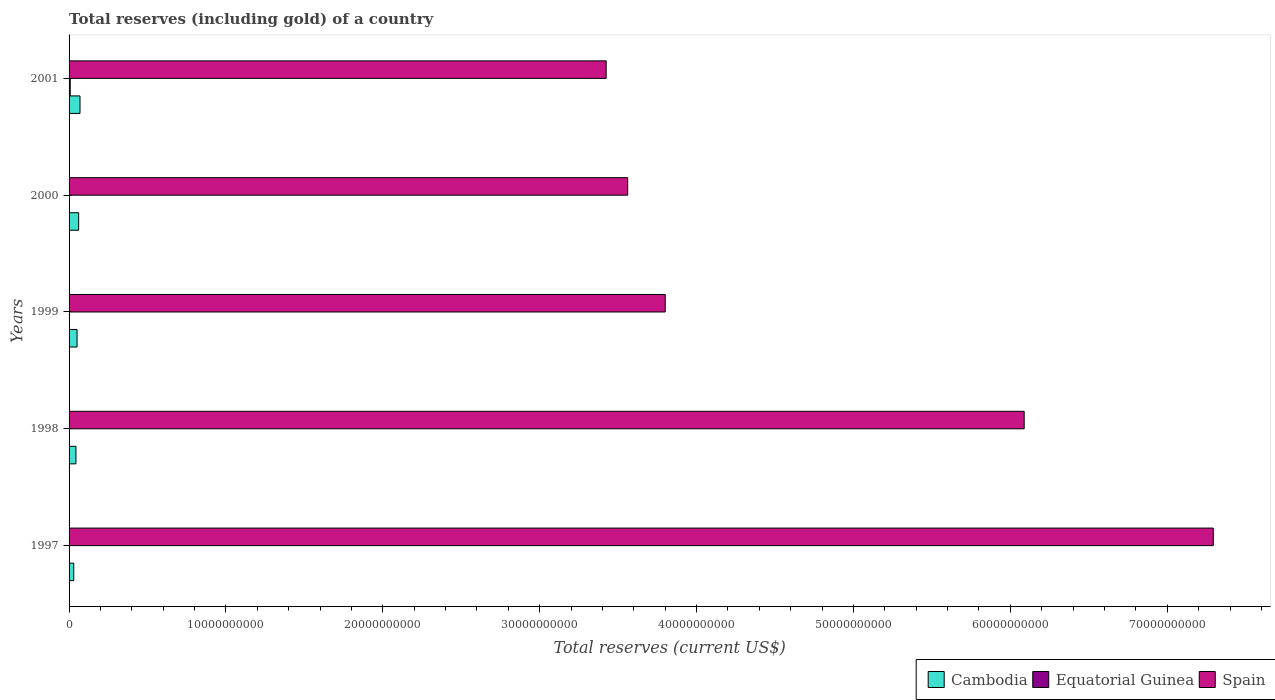How many groups of bars are there?
Your answer should be compact. 5. Are the number of bars per tick equal to the number of legend labels?
Your response must be concise. Yes. Are the number of bars on each tick of the Y-axis equal?
Your answer should be very brief. Yes. How many bars are there on the 3rd tick from the top?
Your response must be concise. 3. How many bars are there on the 1st tick from the bottom?
Your answer should be compact. 3. What is the label of the 1st group of bars from the top?
Keep it short and to the point. 2001. In how many cases, is the number of bars for a given year not equal to the number of legend labels?
Give a very brief answer. 0. What is the total reserves (including gold) in Equatorial Guinea in 1997?
Keep it short and to the point. 4.93e+06. Across all years, what is the maximum total reserves (including gold) in Spain?
Offer a terse response. 7.29e+1. Across all years, what is the minimum total reserves (including gold) in Equatorial Guinea?
Provide a short and direct response. 8.03e+05. In which year was the total reserves (including gold) in Cambodia maximum?
Give a very brief answer. 2001. What is the total total reserves (including gold) in Cambodia in the graph?
Ensure brevity in your answer.  2.56e+09. What is the difference between the total reserves (including gold) in Cambodia in 1999 and that in 2001?
Provide a succinct answer. -1.88e+08. What is the difference between the total reserves (including gold) in Equatorial Guinea in 2000 and the total reserves (including gold) in Cambodia in 1998?
Provide a succinct answer. -4.16e+08. What is the average total reserves (including gold) in Spain per year?
Give a very brief answer. 4.83e+1. In the year 1997, what is the difference between the total reserves (including gold) in Spain and total reserves (including gold) in Equatorial Guinea?
Offer a terse response. 7.29e+1. What is the ratio of the total reserves (including gold) in Cambodia in 1997 to that in 2000?
Offer a terse response. 0.49. Is the difference between the total reserves (including gold) in Spain in 1998 and 2000 greater than the difference between the total reserves (including gold) in Equatorial Guinea in 1998 and 2000?
Your answer should be very brief. Yes. What is the difference between the highest and the second highest total reserves (including gold) in Spain?
Ensure brevity in your answer.  1.21e+1. What is the difference between the highest and the lowest total reserves (including gold) in Cambodia?
Offer a very short reply. 3.99e+08. In how many years, is the total reserves (including gold) in Equatorial Guinea greater than the average total reserves (including gold) in Equatorial Guinea taken over all years?
Make the answer very short. 2. Is the sum of the total reserves (including gold) in Cambodia in 1999 and 2001 greater than the maximum total reserves (including gold) in Equatorial Guinea across all years?
Your answer should be very brief. Yes. What does the 2nd bar from the top in 1997 represents?
Provide a succinct answer. Equatorial Guinea. What does the 1st bar from the bottom in 1998 represents?
Provide a succinct answer. Cambodia. How are the legend labels stacked?
Offer a very short reply. Horizontal. What is the title of the graph?
Your answer should be very brief. Total reserves (including gold) of a country. Does "Syrian Arab Republic" appear as one of the legend labels in the graph?
Ensure brevity in your answer.  No. What is the label or title of the X-axis?
Provide a short and direct response. Total reserves (current US$). What is the Total reserves (current US$) in Cambodia in 1997?
Give a very brief answer. 2.99e+08. What is the Total reserves (current US$) of Equatorial Guinea in 1997?
Your response must be concise. 4.93e+06. What is the Total reserves (current US$) of Spain in 1997?
Your answer should be very brief. 7.29e+1. What is the Total reserves (current US$) of Cambodia in 1998?
Give a very brief answer. 4.39e+08. What is the Total reserves (current US$) of Equatorial Guinea in 1998?
Offer a very short reply. 8.03e+05. What is the Total reserves (current US$) of Spain in 1998?
Your response must be concise. 6.09e+1. What is the Total reserves (current US$) of Cambodia in 1999?
Keep it short and to the point. 5.09e+08. What is the Total reserves (current US$) in Equatorial Guinea in 1999?
Ensure brevity in your answer.  3.35e+06. What is the Total reserves (current US$) in Spain in 1999?
Offer a terse response. 3.80e+1. What is the Total reserves (current US$) in Cambodia in 2000?
Give a very brief answer. 6.11e+08. What is the Total reserves (current US$) in Equatorial Guinea in 2000?
Offer a very short reply. 2.30e+07. What is the Total reserves (current US$) in Spain in 2000?
Offer a terse response. 3.56e+1. What is the Total reserves (current US$) of Cambodia in 2001?
Offer a very short reply. 6.97e+08. What is the Total reserves (current US$) in Equatorial Guinea in 2001?
Ensure brevity in your answer.  7.09e+07. What is the Total reserves (current US$) in Spain in 2001?
Make the answer very short. 3.42e+1. Across all years, what is the maximum Total reserves (current US$) in Cambodia?
Offer a terse response. 6.97e+08. Across all years, what is the maximum Total reserves (current US$) in Equatorial Guinea?
Provide a succinct answer. 7.09e+07. Across all years, what is the maximum Total reserves (current US$) of Spain?
Offer a very short reply. 7.29e+1. Across all years, what is the minimum Total reserves (current US$) in Cambodia?
Your response must be concise. 2.99e+08. Across all years, what is the minimum Total reserves (current US$) of Equatorial Guinea?
Make the answer very short. 8.03e+05. Across all years, what is the minimum Total reserves (current US$) in Spain?
Your answer should be very brief. 3.42e+1. What is the total Total reserves (current US$) in Cambodia in the graph?
Your response must be concise. 2.56e+09. What is the total Total reserves (current US$) of Equatorial Guinea in the graph?
Give a very brief answer. 1.03e+08. What is the total Total reserves (current US$) in Spain in the graph?
Offer a terse response. 2.42e+11. What is the difference between the Total reserves (current US$) in Cambodia in 1997 and that in 1998?
Provide a short and direct response. -1.41e+08. What is the difference between the Total reserves (current US$) of Equatorial Guinea in 1997 and that in 1998?
Offer a very short reply. 4.13e+06. What is the difference between the Total reserves (current US$) of Spain in 1997 and that in 1998?
Your response must be concise. 1.21e+1. What is the difference between the Total reserves (current US$) of Cambodia in 1997 and that in 1999?
Your response must be concise. -2.11e+08. What is the difference between the Total reserves (current US$) in Equatorial Guinea in 1997 and that in 1999?
Offer a terse response. 1.58e+06. What is the difference between the Total reserves (current US$) in Spain in 1997 and that in 1999?
Your answer should be compact. 3.49e+1. What is the difference between the Total reserves (current US$) in Cambodia in 1997 and that in 2000?
Provide a short and direct response. -3.13e+08. What is the difference between the Total reserves (current US$) of Equatorial Guinea in 1997 and that in 2000?
Offer a very short reply. -1.81e+07. What is the difference between the Total reserves (current US$) of Spain in 1997 and that in 2000?
Make the answer very short. 3.73e+1. What is the difference between the Total reserves (current US$) in Cambodia in 1997 and that in 2001?
Make the answer very short. -3.99e+08. What is the difference between the Total reserves (current US$) of Equatorial Guinea in 1997 and that in 2001?
Your answer should be compact. -6.59e+07. What is the difference between the Total reserves (current US$) in Spain in 1997 and that in 2001?
Offer a very short reply. 3.87e+1. What is the difference between the Total reserves (current US$) in Cambodia in 1998 and that in 1999?
Your answer should be very brief. -6.98e+07. What is the difference between the Total reserves (current US$) of Equatorial Guinea in 1998 and that in 1999?
Make the answer very short. -2.55e+06. What is the difference between the Total reserves (current US$) in Spain in 1998 and that in 1999?
Make the answer very short. 2.29e+1. What is the difference between the Total reserves (current US$) of Cambodia in 1998 and that in 2000?
Your response must be concise. -1.72e+08. What is the difference between the Total reserves (current US$) of Equatorial Guinea in 1998 and that in 2000?
Make the answer very short. -2.22e+07. What is the difference between the Total reserves (current US$) of Spain in 1998 and that in 2000?
Keep it short and to the point. 2.53e+1. What is the difference between the Total reserves (current US$) in Cambodia in 1998 and that in 2001?
Provide a short and direct response. -2.58e+08. What is the difference between the Total reserves (current US$) of Equatorial Guinea in 1998 and that in 2001?
Offer a terse response. -7.00e+07. What is the difference between the Total reserves (current US$) in Spain in 1998 and that in 2001?
Your answer should be very brief. 2.66e+1. What is the difference between the Total reserves (current US$) of Cambodia in 1999 and that in 2000?
Your answer should be very brief. -1.02e+08. What is the difference between the Total reserves (current US$) in Equatorial Guinea in 1999 and that in 2000?
Your answer should be very brief. -1.97e+07. What is the difference between the Total reserves (current US$) of Spain in 1999 and that in 2000?
Your response must be concise. 2.39e+09. What is the difference between the Total reserves (current US$) of Cambodia in 1999 and that in 2001?
Keep it short and to the point. -1.88e+08. What is the difference between the Total reserves (current US$) in Equatorial Guinea in 1999 and that in 2001?
Ensure brevity in your answer.  -6.75e+07. What is the difference between the Total reserves (current US$) in Spain in 1999 and that in 2001?
Your response must be concise. 3.76e+09. What is the difference between the Total reserves (current US$) of Cambodia in 2000 and that in 2001?
Your response must be concise. -8.59e+07. What is the difference between the Total reserves (current US$) of Equatorial Guinea in 2000 and that in 2001?
Offer a terse response. -4.78e+07. What is the difference between the Total reserves (current US$) in Spain in 2000 and that in 2001?
Your answer should be very brief. 1.37e+09. What is the difference between the Total reserves (current US$) in Cambodia in 1997 and the Total reserves (current US$) in Equatorial Guinea in 1998?
Ensure brevity in your answer.  2.98e+08. What is the difference between the Total reserves (current US$) of Cambodia in 1997 and the Total reserves (current US$) of Spain in 1998?
Your answer should be compact. -6.06e+1. What is the difference between the Total reserves (current US$) in Equatorial Guinea in 1997 and the Total reserves (current US$) in Spain in 1998?
Offer a very short reply. -6.09e+1. What is the difference between the Total reserves (current US$) in Cambodia in 1997 and the Total reserves (current US$) in Equatorial Guinea in 1999?
Your response must be concise. 2.95e+08. What is the difference between the Total reserves (current US$) in Cambodia in 1997 and the Total reserves (current US$) in Spain in 1999?
Keep it short and to the point. -3.77e+1. What is the difference between the Total reserves (current US$) in Equatorial Guinea in 1997 and the Total reserves (current US$) in Spain in 1999?
Offer a very short reply. -3.80e+1. What is the difference between the Total reserves (current US$) of Cambodia in 1997 and the Total reserves (current US$) of Equatorial Guinea in 2000?
Provide a short and direct response. 2.76e+08. What is the difference between the Total reserves (current US$) in Cambodia in 1997 and the Total reserves (current US$) in Spain in 2000?
Offer a terse response. -3.53e+1. What is the difference between the Total reserves (current US$) in Equatorial Guinea in 1997 and the Total reserves (current US$) in Spain in 2000?
Keep it short and to the point. -3.56e+1. What is the difference between the Total reserves (current US$) in Cambodia in 1997 and the Total reserves (current US$) in Equatorial Guinea in 2001?
Your response must be concise. 2.28e+08. What is the difference between the Total reserves (current US$) in Cambodia in 1997 and the Total reserves (current US$) in Spain in 2001?
Make the answer very short. -3.39e+1. What is the difference between the Total reserves (current US$) of Equatorial Guinea in 1997 and the Total reserves (current US$) of Spain in 2001?
Offer a very short reply. -3.42e+1. What is the difference between the Total reserves (current US$) in Cambodia in 1998 and the Total reserves (current US$) in Equatorial Guinea in 1999?
Your response must be concise. 4.36e+08. What is the difference between the Total reserves (current US$) of Cambodia in 1998 and the Total reserves (current US$) of Spain in 1999?
Your answer should be compact. -3.76e+1. What is the difference between the Total reserves (current US$) in Equatorial Guinea in 1998 and the Total reserves (current US$) in Spain in 1999?
Offer a terse response. -3.80e+1. What is the difference between the Total reserves (current US$) in Cambodia in 1998 and the Total reserves (current US$) in Equatorial Guinea in 2000?
Your answer should be very brief. 4.16e+08. What is the difference between the Total reserves (current US$) in Cambodia in 1998 and the Total reserves (current US$) in Spain in 2000?
Your response must be concise. -3.52e+1. What is the difference between the Total reserves (current US$) in Equatorial Guinea in 1998 and the Total reserves (current US$) in Spain in 2000?
Make the answer very short. -3.56e+1. What is the difference between the Total reserves (current US$) of Cambodia in 1998 and the Total reserves (current US$) of Equatorial Guinea in 2001?
Keep it short and to the point. 3.69e+08. What is the difference between the Total reserves (current US$) of Cambodia in 1998 and the Total reserves (current US$) of Spain in 2001?
Make the answer very short. -3.38e+1. What is the difference between the Total reserves (current US$) in Equatorial Guinea in 1998 and the Total reserves (current US$) in Spain in 2001?
Provide a succinct answer. -3.42e+1. What is the difference between the Total reserves (current US$) of Cambodia in 1999 and the Total reserves (current US$) of Equatorial Guinea in 2000?
Offer a terse response. 4.86e+08. What is the difference between the Total reserves (current US$) of Cambodia in 1999 and the Total reserves (current US$) of Spain in 2000?
Make the answer very short. -3.51e+1. What is the difference between the Total reserves (current US$) of Equatorial Guinea in 1999 and the Total reserves (current US$) of Spain in 2000?
Offer a terse response. -3.56e+1. What is the difference between the Total reserves (current US$) in Cambodia in 1999 and the Total reserves (current US$) in Equatorial Guinea in 2001?
Your response must be concise. 4.38e+08. What is the difference between the Total reserves (current US$) of Cambodia in 1999 and the Total reserves (current US$) of Spain in 2001?
Provide a short and direct response. -3.37e+1. What is the difference between the Total reserves (current US$) in Equatorial Guinea in 1999 and the Total reserves (current US$) in Spain in 2001?
Your answer should be compact. -3.42e+1. What is the difference between the Total reserves (current US$) of Cambodia in 2000 and the Total reserves (current US$) of Equatorial Guinea in 2001?
Your answer should be very brief. 5.41e+08. What is the difference between the Total reserves (current US$) of Cambodia in 2000 and the Total reserves (current US$) of Spain in 2001?
Ensure brevity in your answer.  -3.36e+1. What is the difference between the Total reserves (current US$) of Equatorial Guinea in 2000 and the Total reserves (current US$) of Spain in 2001?
Your answer should be compact. -3.42e+1. What is the average Total reserves (current US$) of Cambodia per year?
Ensure brevity in your answer.  5.11e+08. What is the average Total reserves (current US$) of Equatorial Guinea per year?
Ensure brevity in your answer.  2.06e+07. What is the average Total reserves (current US$) in Spain per year?
Provide a short and direct response. 4.83e+1. In the year 1997, what is the difference between the Total reserves (current US$) in Cambodia and Total reserves (current US$) in Equatorial Guinea?
Provide a succinct answer. 2.94e+08. In the year 1997, what is the difference between the Total reserves (current US$) in Cambodia and Total reserves (current US$) in Spain?
Offer a very short reply. -7.26e+1. In the year 1997, what is the difference between the Total reserves (current US$) of Equatorial Guinea and Total reserves (current US$) of Spain?
Provide a succinct answer. -7.29e+1. In the year 1998, what is the difference between the Total reserves (current US$) in Cambodia and Total reserves (current US$) in Equatorial Guinea?
Your answer should be very brief. 4.39e+08. In the year 1998, what is the difference between the Total reserves (current US$) of Cambodia and Total reserves (current US$) of Spain?
Keep it short and to the point. -6.04e+1. In the year 1998, what is the difference between the Total reserves (current US$) in Equatorial Guinea and Total reserves (current US$) in Spain?
Make the answer very short. -6.09e+1. In the year 1999, what is the difference between the Total reserves (current US$) of Cambodia and Total reserves (current US$) of Equatorial Guinea?
Offer a terse response. 5.06e+08. In the year 1999, what is the difference between the Total reserves (current US$) of Cambodia and Total reserves (current US$) of Spain?
Your answer should be very brief. -3.75e+1. In the year 1999, what is the difference between the Total reserves (current US$) of Equatorial Guinea and Total reserves (current US$) of Spain?
Offer a terse response. -3.80e+1. In the year 2000, what is the difference between the Total reserves (current US$) in Cambodia and Total reserves (current US$) in Equatorial Guinea?
Make the answer very short. 5.88e+08. In the year 2000, what is the difference between the Total reserves (current US$) of Cambodia and Total reserves (current US$) of Spain?
Provide a succinct answer. -3.50e+1. In the year 2000, what is the difference between the Total reserves (current US$) in Equatorial Guinea and Total reserves (current US$) in Spain?
Your answer should be compact. -3.56e+1. In the year 2001, what is the difference between the Total reserves (current US$) in Cambodia and Total reserves (current US$) in Equatorial Guinea?
Offer a terse response. 6.27e+08. In the year 2001, what is the difference between the Total reserves (current US$) in Cambodia and Total reserves (current US$) in Spain?
Provide a succinct answer. -3.35e+1. In the year 2001, what is the difference between the Total reserves (current US$) in Equatorial Guinea and Total reserves (current US$) in Spain?
Provide a succinct answer. -3.42e+1. What is the ratio of the Total reserves (current US$) in Cambodia in 1997 to that in 1998?
Provide a succinct answer. 0.68. What is the ratio of the Total reserves (current US$) of Equatorial Guinea in 1997 to that in 1998?
Keep it short and to the point. 6.14. What is the ratio of the Total reserves (current US$) of Spain in 1997 to that in 1998?
Offer a very short reply. 1.2. What is the ratio of the Total reserves (current US$) in Cambodia in 1997 to that in 1999?
Make the answer very short. 0.59. What is the ratio of the Total reserves (current US$) in Equatorial Guinea in 1997 to that in 1999?
Provide a succinct answer. 1.47. What is the ratio of the Total reserves (current US$) in Spain in 1997 to that in 1999?
Provide a succinct answer. 1.92. What is the ratio of the Total reserves (current US$) of Cambodia in 1997 to that in 2000?
Your answer should be very brief. 0.49. What is the ratio of the Total reserves (current US$) of Equatorial Guinea in 1997 to that in 2000?
Ensure brevity in your answer.  0.21. What is the ratio of the Total reserves (current US$) in Spain in 1997 to that in 2000?
Provide a short and direct response. 2.05. What is the ratio of the Total reserves (current US$) of Cambodia in 1997 to that in 2001?
Offer a terse response. 0.43. What is the ratio of the Total reserves (current US$) of Equatorial Guinea in 1997 to that in 2001?
Give a very brief answer. 0.07. What is the ratio of the Total reserves (current US$) of Spain in 1997 to that in 2001?
Provide a short and direct response. 2.13. What is the ratio of the Total reserves (current US$) in Cambodia in 1998 to that in 1999?
Keep it short and to the point. 0.86. What is the ratio of the Total reserves (current US$) in Equatorial Guinea in 1998 to that in 1999?
Your answer should be very brief. 0.24. What is the ratio of the Total reserves (current US$) of Spain in 1998 to that in 1999?
Offer a very short reply. 1.6. What is the ratio of the Total reserves (current US$) of Cambodia in 1998 to that in 2000?
Make the answer very short. 0.72. What is the ratio of the Total reserves (current US$) in Equatorial Guinea in 1998 to that in 2000?
Your answer should be very brief. 0.03. What is the ratio of the Total reserves (current US$) of Spain in 1998 to that in 2000?
Provide a succinct answer. 1.71. What is the ratio of the Total reserves (current US$) in Cambodia in 1998 to that in 2001?
Provide a short and direct response. 0.63. What is the ratio of the Total reserves (current US$) in Equatorial Guinea in 1998 to that in 2001?
Make the answer very short. 0.01. What is the ratio of the Total reserves (current US$) in Spain in 1998 to that in 2001?
Offer a very short reply. 1.78. What is the ratio of the Total reserves (current US$) of Cambodia in 1999 to that in 2000?
Your answer should be very brief. 0.83. What is the ratio of the Total reserves (current US$) in Equatorial Guinea in 1999 to that in 2000?
Ensure brevity in your answer.  0.15. What is the ratio of the Total reserves (current US$) of Spain in 1999 to that in 2000?
Offer a very short reply. 1.07. What is the ratio of the Total reserves (current US$) in Cambodia in 1999 to that in 2001?
Offer a very short reply. 0.73. What is the ratio of the Total reserves (current US$) in Equatorial Guinea in 1999 to that in 2001?
Provide a short and direct response. 0.05. What is the ratio of the Total reserves (current US$) in Spain in 1999 to that in 2001?
Provide a short and direct response. 1.11. What is the ratio of the Total reserves (current US$) of Cambodia in 2000 to that in 2001?
Offer a terse response. 0.88. What is the ratio of the Total reserves (current US$) in Equatorial Guinea in 2000 to that in 2001?
Provide a short and direct response. 0.32. What is the ratio of the Total reserves (current US$) in Spain in 2000 to that in 2001?
Your answer should be very brief. 1.04. What is the difference between the highest and the second highest Total reserves (current US$) of Cambodia?
Provide a short and direct response. 8.59e+07. What is the difference between the highest and the second highest Total reserves (current US$) of Equatorial Guinea?
Your answer should be compact. 4.78e+07. What is the difference between the highest and the second highest Total reserves (current US$) of Spain?
Provide a succinct answer. 1.21e+1. What is the difference between the highest and the lowest Total reserves (current US$) in Cambodia?
Keep it short and to the point. 3.99e+08. What is the difference between the highest and the lowest Total reserves (current US$) in Equatorial Guinea?
Provide a succinct answer. 7.00e+07. What is the difference between the highest and the lowest Total reserves (current US$) in Spain?
Keep it short and to the point. 3.87e+1. 